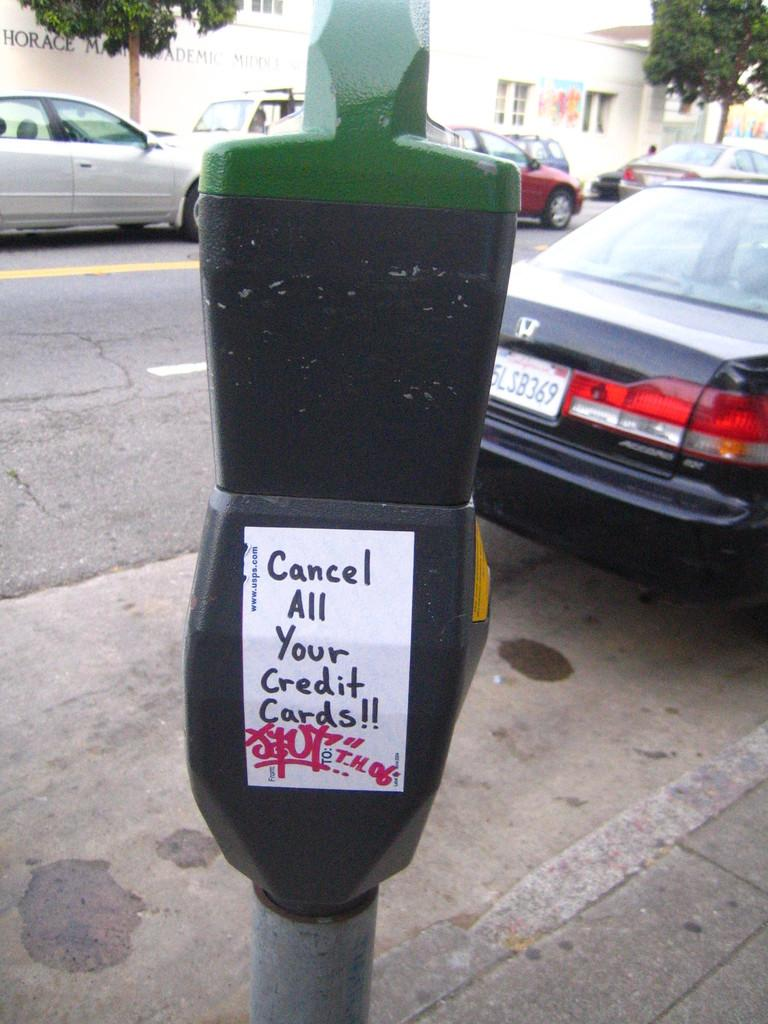<image>
Describe the image concisely. A meter in the city with a message hand written to cancel credit cards. 